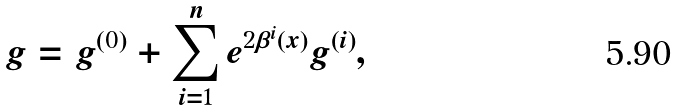<formula> <loc_0><loc_0><loc_500><loc_500>g = g ^ { ( 0 ) } + \sum _ { i = 1 } ^ { n } e ^ { 2 \beta ^ { i } ( x ) } g ^ { ( i ) } ,</formula> 